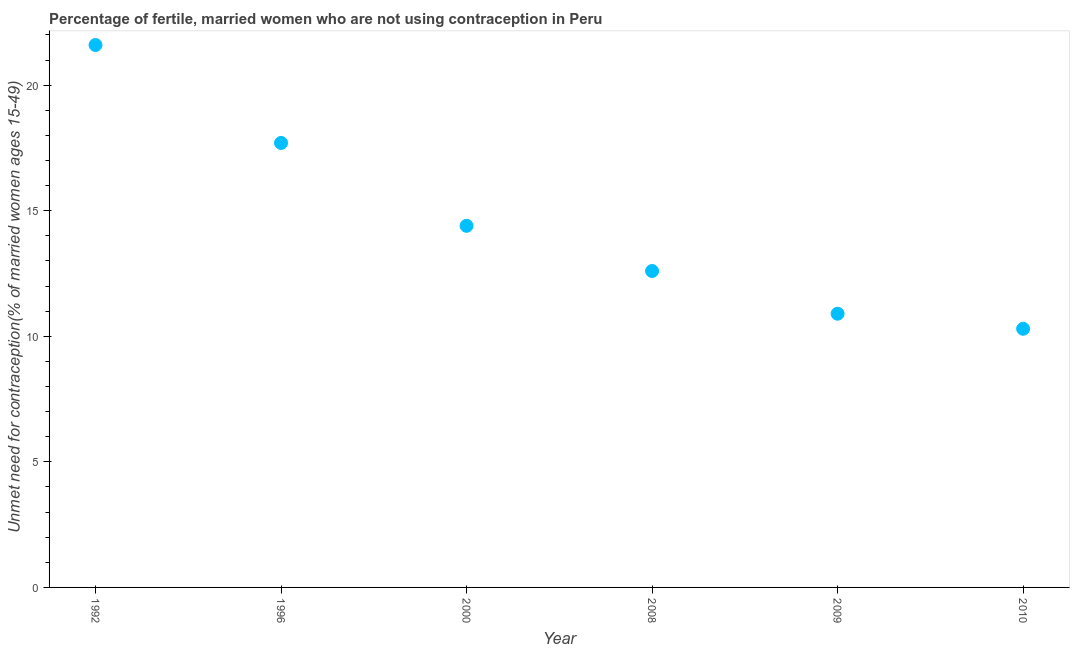Across all years, what is the maximum number of married women who are not using contraception?
Your response must be concise. 21.6. Across all years, what is the minimum number of married women who are not using contraception?
Your answer should be very brief. 10.3. What is the sum of the number of married women who are not using contraception?
Offer a terse response. 87.5. What is the difference between the number of married women who are not using contraception in 1992 and 2008?
Provide a succinct answer. 9. What is the average number of married women who are not using contraception per year?
Offer a terse response. 14.58. What is the median number of married women who are not using contraception?
Your answer should be compact. 13.5. In how many years, is the number of married women who are not using contraception greater than 10 %?
Give a very brief answer. 6. Do a majority of the years between 2009 and 1996 (inclusive) have number of married women who are not using contraception greater than 13 %?
Give a very brief answer. Yes. What is the ratio of the number of married women who are not using contraception in 2000 to that in 2010?
Give a very brief answer. 1.4. Is the number of married women who are not using contraception in 2000 less than that in 2009?
Offer a very short reply. No. Is the difference between the number of married women who are not using contraception in 2009 and 2010 greater than the difference between any two years?
Offer a terse response. No. What is the difference between the highest and the second highest number of married women who are not using contraception?
Make the answer very short. 3.9. What is the difference between the highest and the lowest number of married women who are not using contraception?
Keep it short and to the point. 11.3. In how many years, is the number of married women who are not using contraception greater than the average number of married women who are not using contraception taken over all years?
Your answer should be compact. 2. How many dotlines are there?
Provide a short and direct response. 1. Does the graph contain any zero values?
Give a very brief answer. No. Does the graph contain grids?
Provide a succinct answer. No. What is the title of the graph?
Provide a succinct answer. Percentage of fertile, married women who are not using contraception in Peru. What is the label or title of the Y-axis?
Your answer should be compact.  Unmet need for contraception(% of married women ages 15-49). What is the  Unmet need for contraception(% of married women ages 15-49) in 1992?
Your response must be concise. 21.6. What is the  Unmet need for contraception(% of married women ages 15-49) in 2009?
Give a very brief answer. 10.9. What is the difference between the  Unmet need for contraception(% of married women ages 15-49) in 1992 and 1996?
Keep it short and to the point. 3.9. What is the difference between the  Unmet need for contraception(% of married women ages 15-49) in 1992 and 2008?
Give a very brief answer. 9. What is the difference between the  Unmet need for contraception(% of married women ages 15-49) in 1996 and 2008?
Offer a very short reply. 5.1. What is the difference between the  Unmet need for contraception(% of married women ages 15-49) in 1996 and 2010?
Provide a short and direct response. 7.4. What is the difference between the  Unmet need for contraception(% of married women ages 15-49) in 2000 and 2008?
Provide a short and direct response. 1.8. What is the difference between the  Unmet need for contraception(% of married women ages 15-49) in 2000 and 2010?
Your answer should be compact. 4.1. What is the difference between the  Unmet need for contraception(% of married women ages 15-49) in 2008 and 2010?
Your answer should be compact. 2.3. What is the difference between the  Unmet need for contraception(% of married women ages 15-49) in 2009 and 2010?
Your answer should be compact. 0.6. What is the ratio of the  Unmet need for contraception(% of married women ages 15-49) in 1992 to that in 1996?
Your response must be concise. 1.22. What is the ratio of the  Unmet need for contraception(% of married women ages 15-49) in 1992 to that in 2008?
Give a very brief answer. 1.71. What is the ratio of the  Unmet need for contraception(% of married women ages 15-49) in 1992 to that in 2009?
Make the answer very short. 1.98. What is the ratio of the  Unmet need for contraception(% of married women ages 15-49) in 1992 to that in 2010?
Keep it short and to the point. 2.1. What is the ratio of the  Unmet need for contraception(% of married women ages 15-49) in 1996 to that in 2000?
Offer a very short reply. 1.23. What is the ratio of the  Unmet need for contraception(% of married women ages 15-49) in 1996 to that in 2008?
Your answer should be compact. 1.41. What is the ratio of the  Unmet need for contraception(% of married women ages 15-49) in 1996 to that in 2009?
Provide a succinct answer. 1.62. What is the ratio of the  Unmet need for contraception(% of married women ages 15-49) in 1996 to that in 2010?
Provide a succinct answer. 1.72. What is the ratio of the  Unmet need for contraception(% of married women ages 15-49) in 2000 to that in 2008?
Provide a short and direct response. 1.14. What is the ratio of the  Unmet need for contraception(% of married women ages 15-49) in 2000 to that in 2009?
Your response must be concise. 1.32. What is the ratio of the  Unmet need for contraception(% of married women ages 15-49) in 2000 to that in 2010?
Ensure brevity in your answer.  1.4. What is the ratio of the  Unmet need for contraception(% of married women ages 15-49) in 2008 to that in 2009?
Provide a short and direct response. 1.16. What is the ratio of the  Unmet need for contraception(% of married women ages 15-49) in 2008 to that in 2010?
Your answer should be very brief. 1.22. What is the ratio of the  Unmet need for contraception(% of married women ages 15-49) in 2009 to that in 2010?
Your response must be concise. 1.06. 